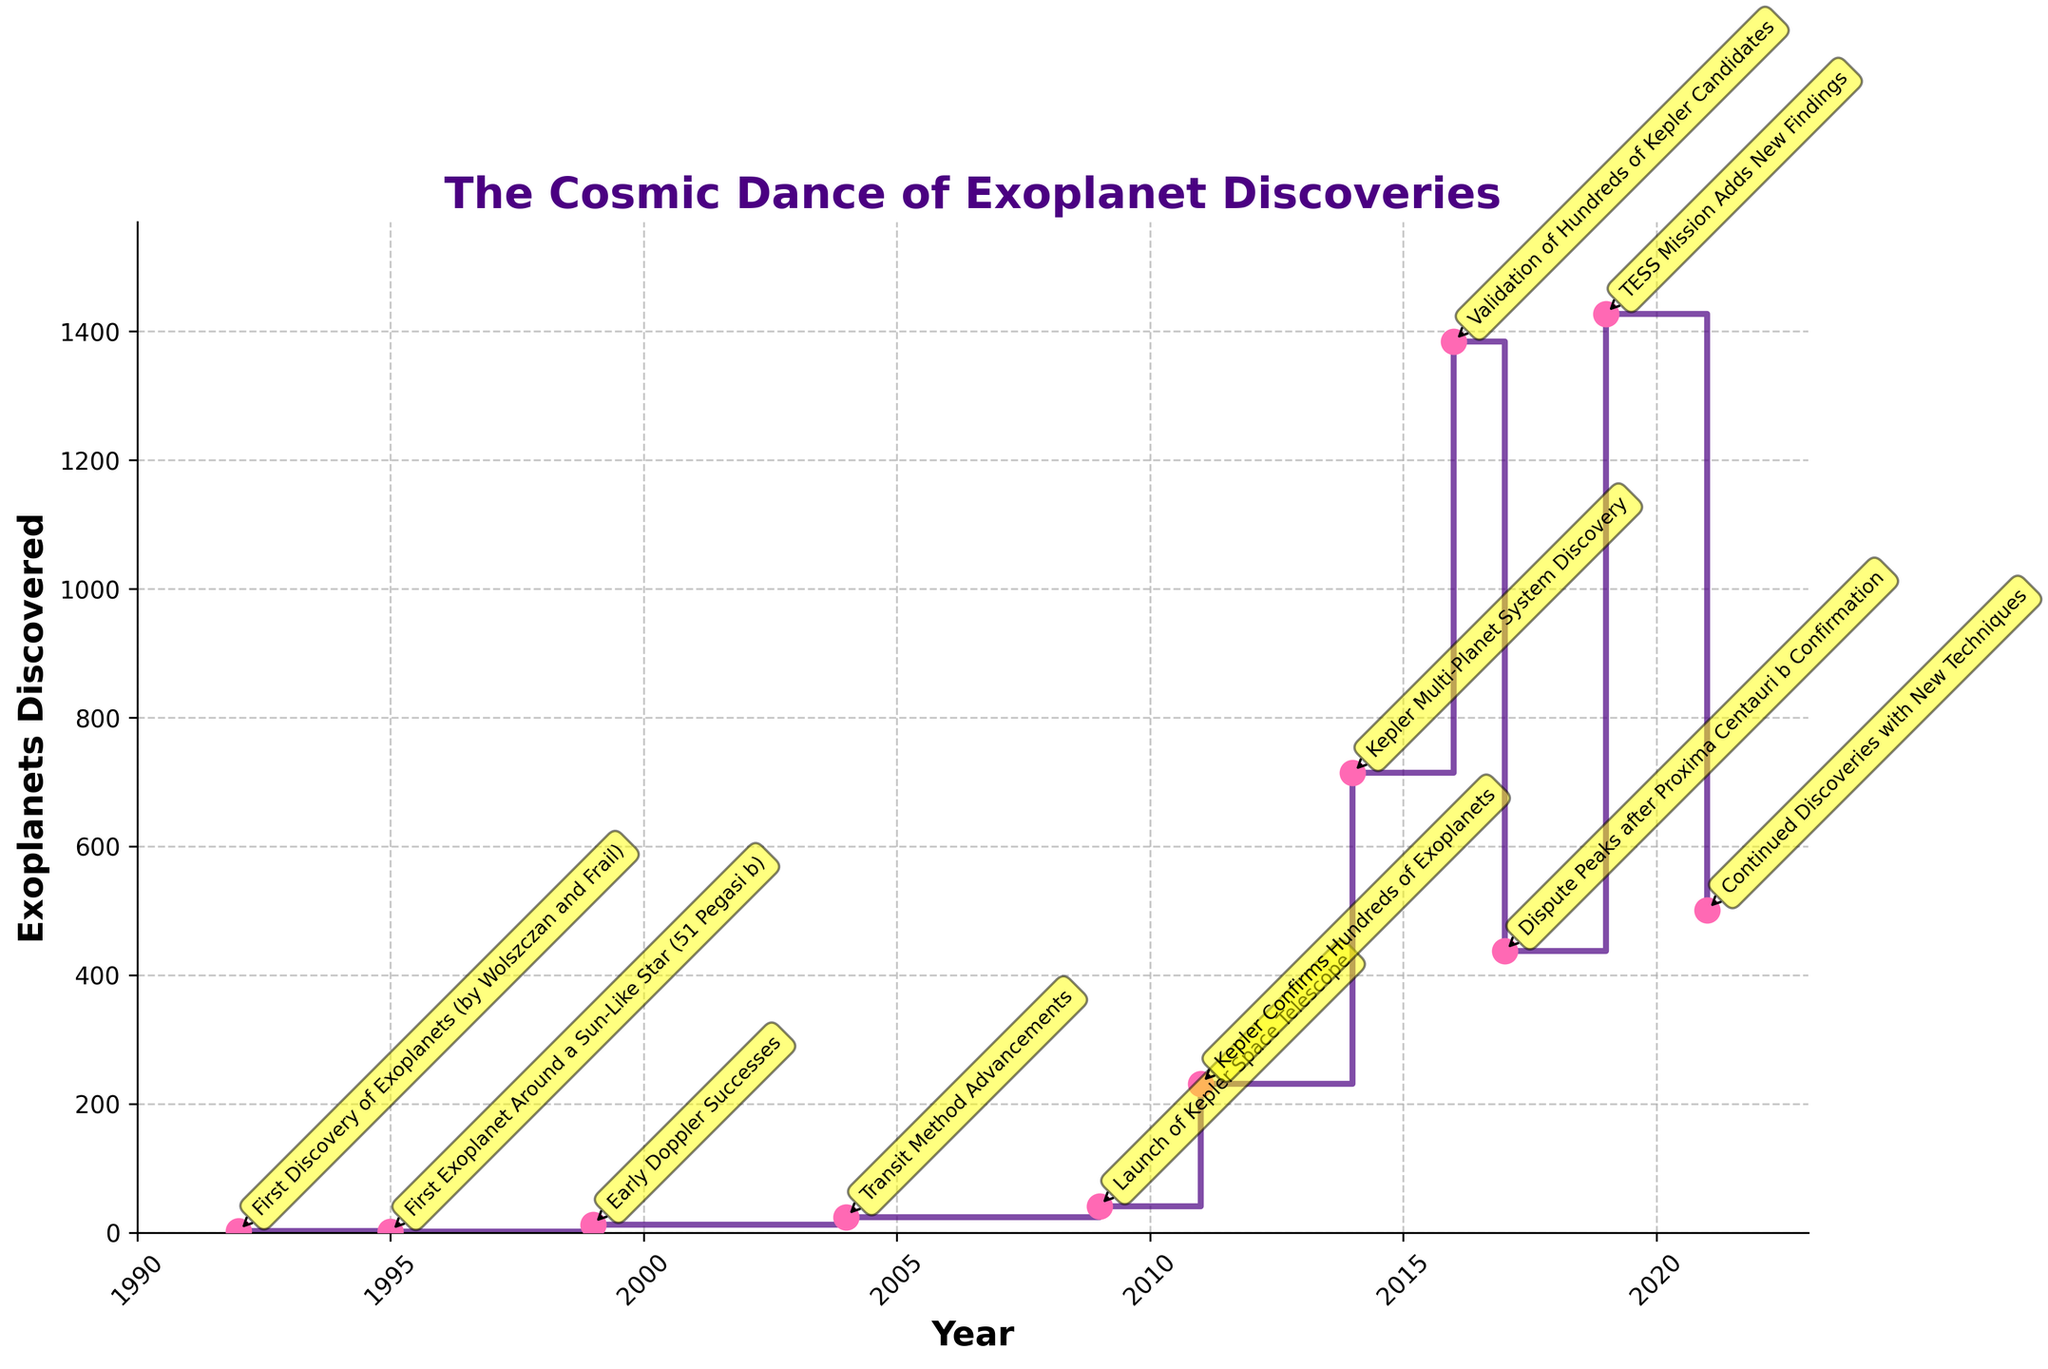When did the first exoplanet discovery occur? To find the first discovery, look at the earliest year in the data set with discoveries. The plot highlights 1992 with an annotation.
Answer: 1992 Which year saw the largest jump in exoplanet discoveries? Observe the stair plot for the steepest upward step. The largest jump is between 2014 and 2016, as indicated by the dramatic rise from 714 to 1384 discoveries.
Answer: 2016 What was the notable event in 2017 mentioned in the plot? Locate the annotation for 2017 on the plot. It references "Dispute Peaks after Proxima Centauri b Confirmation."
Answer: Dispute Peaks after Proxima Centauri b Confirmation How many exoplanets were discovered in total from 2009 to 2011? Sum the number of discoveries from 2009 (41), 2010 (although not shown, context implies fewer discoveries), and 2011 (231). The summation is 41 + 231.
Answer: 272 Which remarkable event coincided with the launch of the Kepler Space Telescope? Check the annotation for the year 2009 on the stair plot. It references "Launch of Kepler Space Telescope."
Answer: Launch of Kepler Space Telescope Between which two consecutive years did the number of discovered exoplanets more than double? Look for a step where the y-value more than doubles from one year to the next. The jump from 231 in 2011 to 714 in 2014 is over three times an increase.
Answer: 2011 and 2014 Which year had fewer exoplanets discovered: 1995 or 1999? Compare the two years by checking their y-values. In 1995, 1 exoplanet was discovered, whereas in 1999, 12 were discovered.
Answer: 1995 What was the total number of exoplanets discovered by 2016? Sum the cumulative discoveries up to 2016 from the data: 2+1+12+24+41+231+714+1384. The total is 2409.
Answer: 2409 Which remarkable event demonstrated the biggest increase in exoplanet discoveries? Compare the effects of notable events. The "Validation of Hundreds of Kepler Candidates" in 2016 shows the biggest increase from 714 to 1384 discoveries.
Answer: Validation of Hundreds of Kepler Candidates How did the number of discoveries change between 2017 to 2019? Calculate the difference between 2019 (1427) and 2017 (437). The increase is 1427 - 437.
Answer: 990 